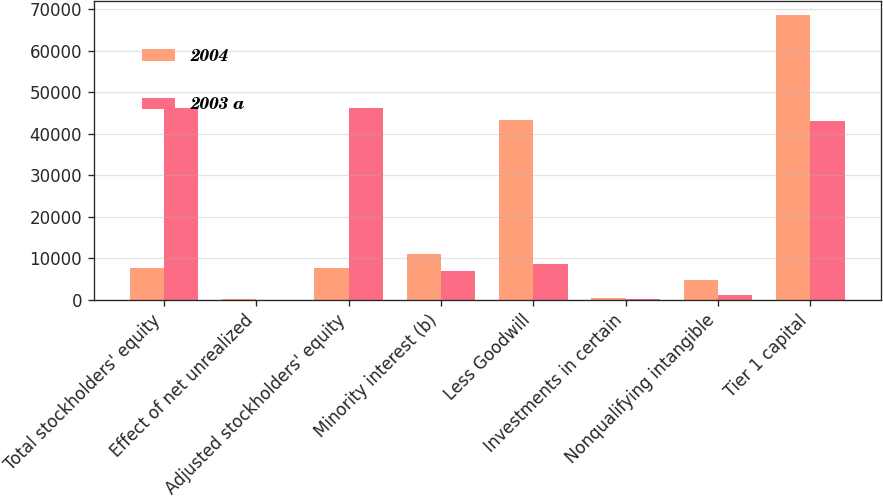Convert chart to OTSL. <chart><loc_0><loc_0><loc_500><loc_500><stacked_bar_chart><ecel><fcel>Total stockholders' equity<fcel>Effect of net unrealized<fcel>Adjusted stockholders' equity<fcel>Minority interest (b)<fcel>Less Goodwill<fcel>Investments in certain<fcel>Nonqualifying intangible<fcel>Tier 1 capital<nl><fcel>2004<fcel>7696.5<fcel>200<fcel>7696.5<fcel>11050<fcel>43203<fcel>370<fcel>4709<fcel>68621<nl><fcel>2003 a<fcel>46154<fcel>24<fcel>46178<fcel>6882<fcel>8511<fcel>266<fcel>1116<fcel>43167<nl></chart> 